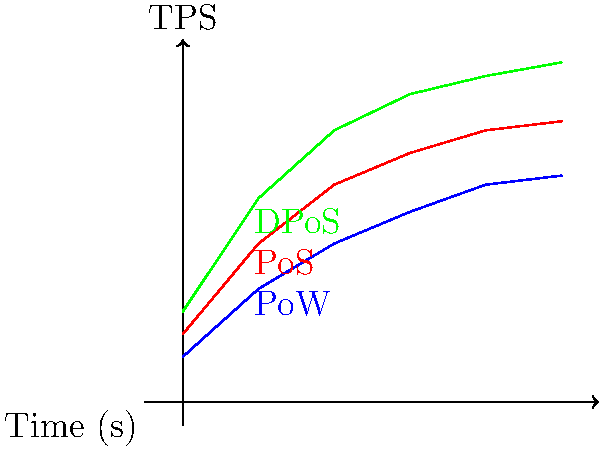Based on the performance metric graph comparing the efficiency of different consensus algorithms, which algorithm demonstrates the highest transactions per second (TPS) after 5 seconds, and what factors might contribute to its superior performance in blockchain networks? To answer this question, let's analyze the graph step-by-step:

1. The graph shows the performance of three consensus algorithms: Proof of Work (PoW), Proof of Stake (PoS), and Delegated Proof of Stake (DPoS).

2. The x-axis represents time in seconds, while the y-axis represents transactions per second (TPS).

3. At the 5-second mark:
   - PoW (blue line) reaches approximately 50 TPS
   - PoS (red line) reaches approximately 62 TPS
   - DPoS (green line) reaches approximately 75 TPS

4. Clearly, DPoS demonstrates the highest TPS after 5 seconds.

5. Factors contributing to DPoS's superior performance:

   a) Reduced number of validators: DPoS uses a smaller set of elected validators, which decreases the time required for consensus.
   
   b) Faster block creation: With fewer validators, blocks can be produced more quickly, increasing overall throughput.
   
   c) Parallel processing: DPoS allows for some degree of parallel transaction processing, further improving TPS.
   
   d) Optimized network communication: With fewer nodes involved in consensus, network overhead is reduced.
   
   e) Incentive structure: DPoS encourages validators to maintain high-performance infrastructure to retain their positions.

6. However, it's important to note that this improved performance comes with trade-offs in decentralization, as DPoS relies on a smaller set of validators compared to PoW or PoS systems.
Answer: DPoS, due to fewer validators, faster block creation, and optimized network communication. 